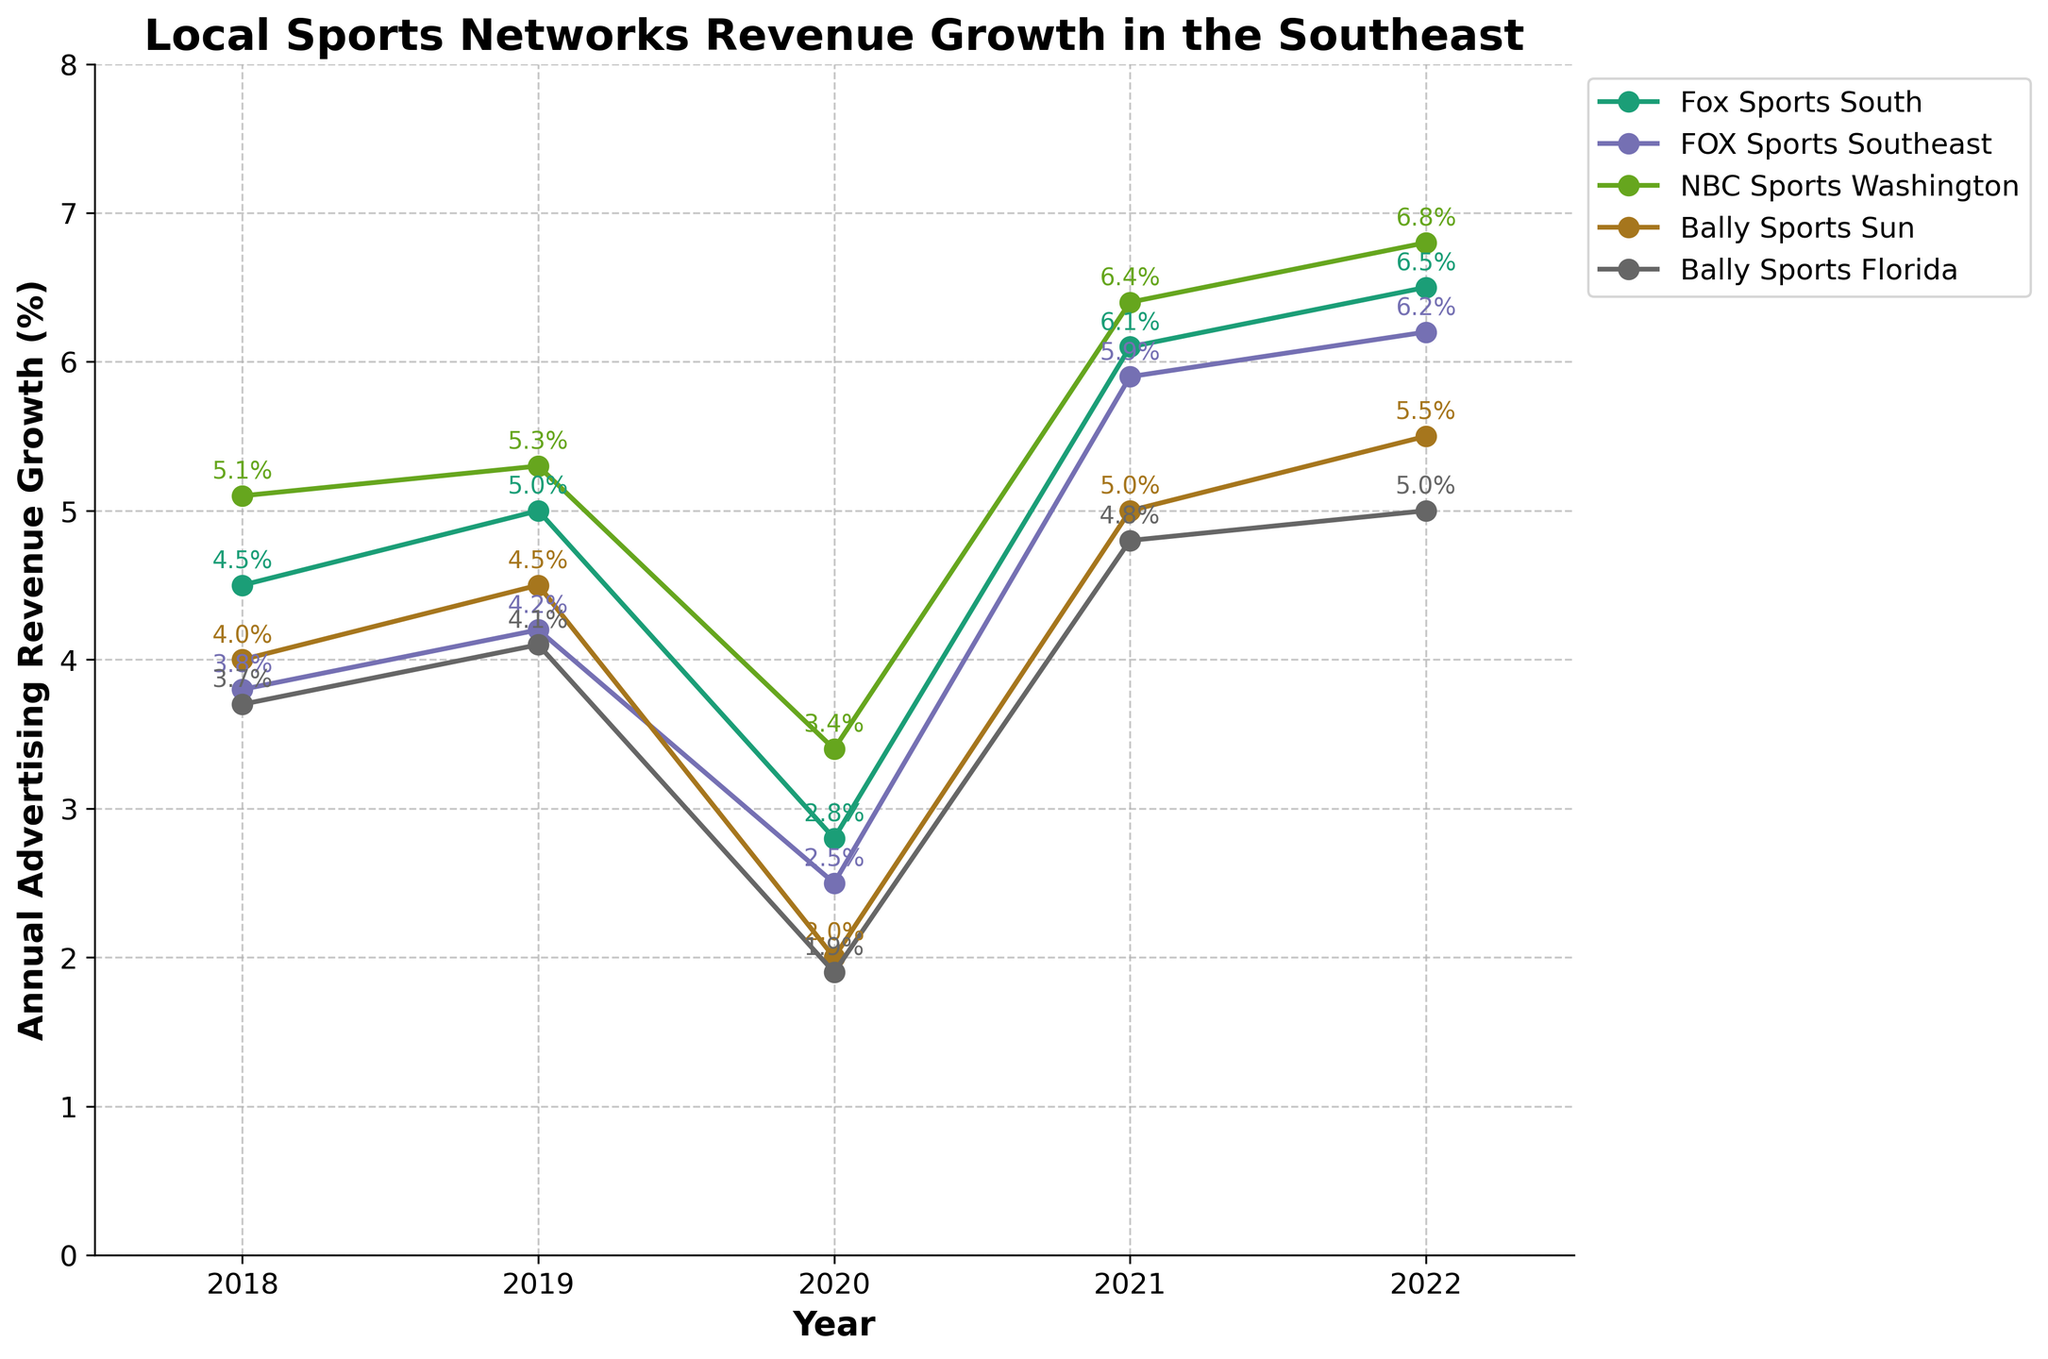Which network had the highest revenue growth in 2022? Locate the data points for 2022 on the x-axis and check the y-values for each network. NBC Sports Washington at 6.8% has the highest value.
Answer: NBC Sports Washington How did the revenue growth of Fox Sports South change from 2019 to 2020? Identify the y-values for Fox Sports South in 2019 (5.0%) and 2020 (2.8%) and calculate the difference. The change is 5.0% - 2.8% = -2.2%.
Answer: Decreased by 2.2% What is the overall trend in annual advertising revenue growth for Bally Sports Sun from 2018 to 2022? Analyze the trend of Bally Sports Sun by checking its y-values across the years: 2018 (4.0%), 2019 (4.5%), 2020 (2.0%), 2021 (5.0%), and 2022 (5.5%). Over the years, we see it decreased in 2020, then increased steadily.
Answer: Increasing with a dip in 2020 Which network had the lowest revenue growth in 2020, and what was the value? Locate the data points for 2020 on the x-axis and find the smallest y-value. Bally Sports Florida at 1.9% has the lowest value.
Answer: Bally Sports Florida, 1.9% Compare the revenue growth of NBC Sports Washington and FOX Sports Southeast in 2021. Which one had higher growth, and by how much? Find the y-values for both networks in 2021: NBC Sports Washington (6.4%) and FOX Sports Southeast (5.9%). The difference is 6.4% - 5.9% = 0.5%.
Answer: NBC Sports Washington, by 0.5% What was the average revenue growth of NBC Sports Washington from 2018 to 2022? Extract the y-values for NBC Sports Washington: 2018 (5.1%), 2019 (5.3%), 2020 (3.4%), 2021 (6.4%), and 2022 (6.8%). Sum these values and divide by the number of data points: (5.1 + 5.3 + 3.4 + 6.4 + 6.8) / 5 = 5.4%.
Answer: 5.4% Which year did all networks experience their lowest combined revenue growth? Calculate the sum of the y-values for each year and identify the lowest total. 2020 combined total: Fox Sports South (2.8%) + FOX Sports Southeast (2.5%) + NBC Sports Washington (3.4%) + Bally Sports Sun (2.0%) + Bally Sports Florida (1.9%) = 12.6%.
Answer: 2020 What is the difference in revenue growth between the highest and lowest performing networks in 2022? Identify the highest and lowest y-values in 2022. Highest: NBC Sports Washington (6.8%), lowest: Bally Sports Florida (5.0%). Difference: 6.8% - 5.0% = 1.8%.
Answer: 1.8% If a network had an average revenue growth of 5.0% or more across the years, how many networks meet this criterion? Calculate the average revenue growth for each network: 
- Fox Sports South: (4.5 + 5.0 + 2.8 + 6.1 + 6.5) / 5 = 5.0%
- FOX Sports Southeast: (3.8 + 4.2 + 2.5 + 5.9 + 6.2) / 5 = 4.52%
- NBC Sports Washington: (5.1 + 5.3 + 3.4 + 6.4 + 6.8) / 5 = 5.4%
- Bally Sports Sun: (4.0 + 4.5 + 2.0 + 5.0 + 5.5) / 5 = 4.2%
- Bally Sports Florida: (3.7 + 4.1 + 1.9 + 4.8 + 5.0) / 5 = 3.9% 
Only NBC Sports Washington meets the criterion.
Answer: 1 